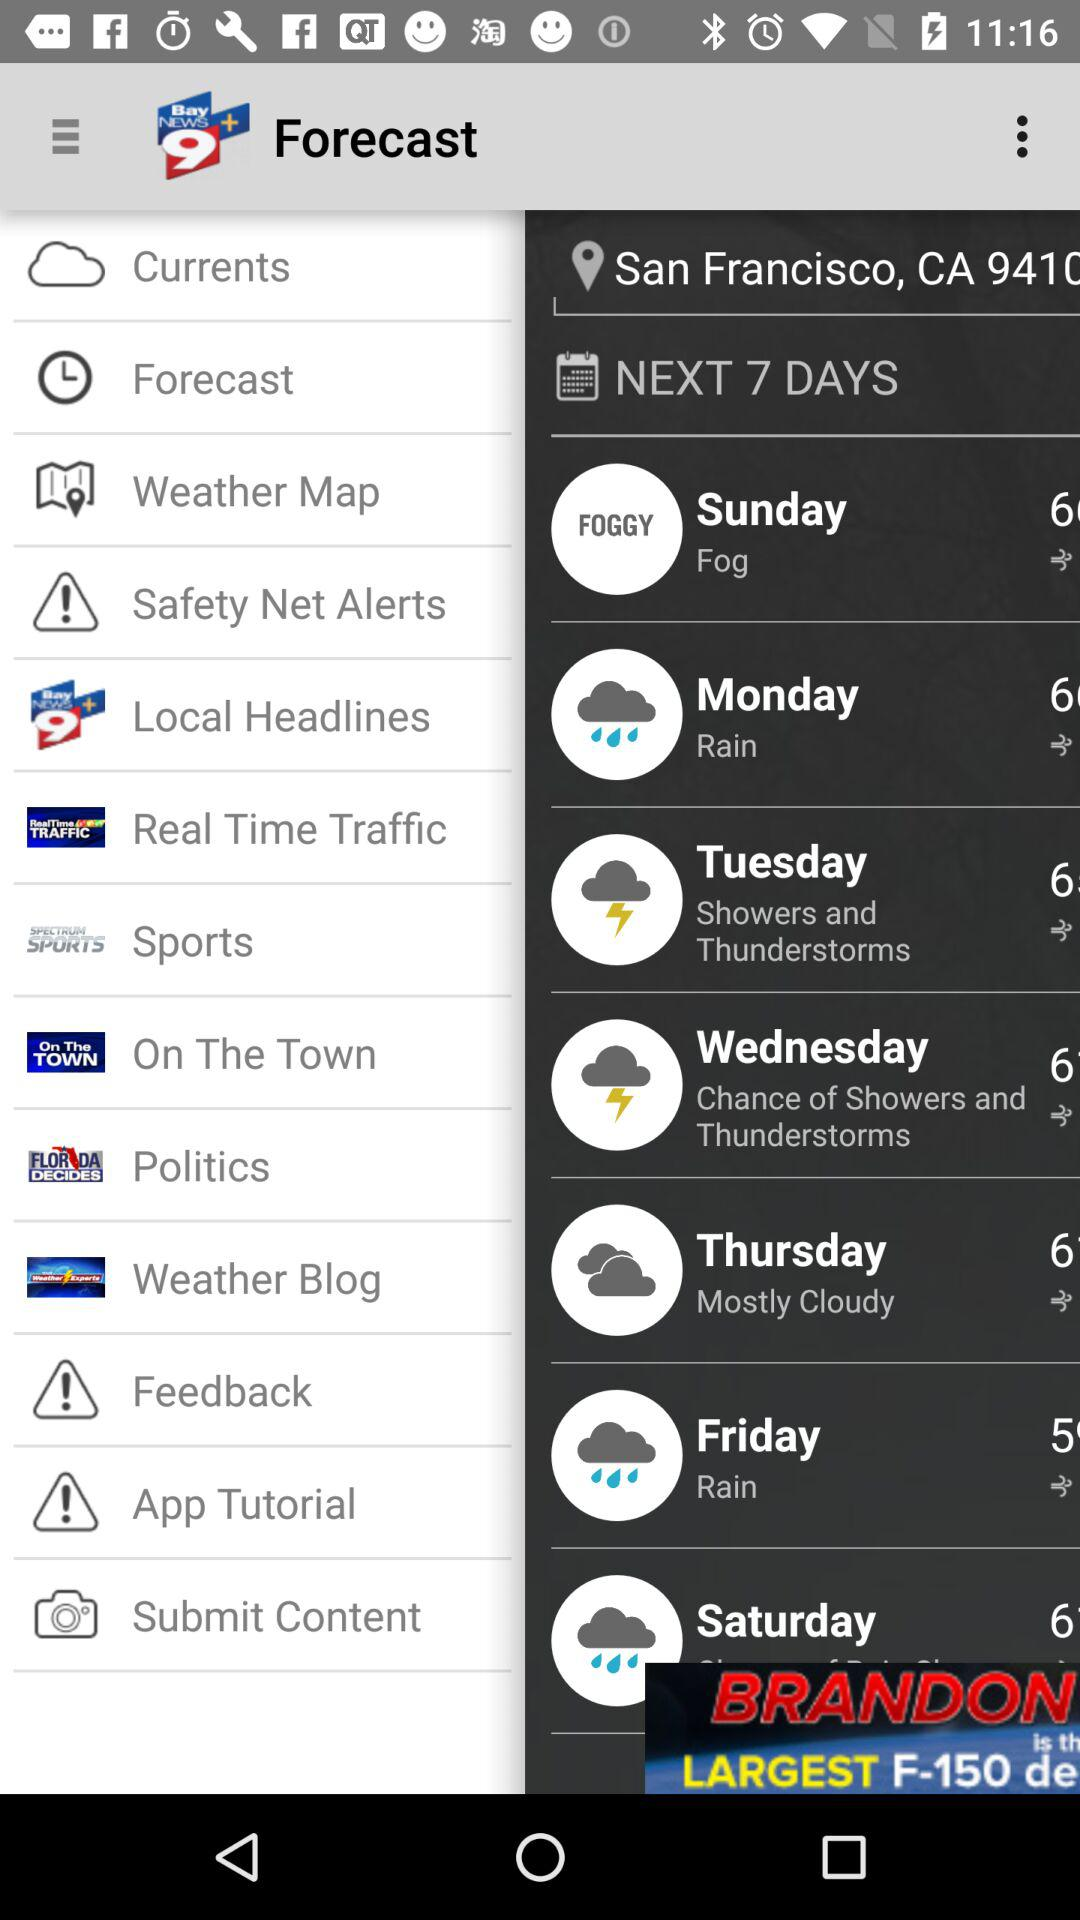What is the name of the application? The name of the application is "Bay News 9 Plus". 